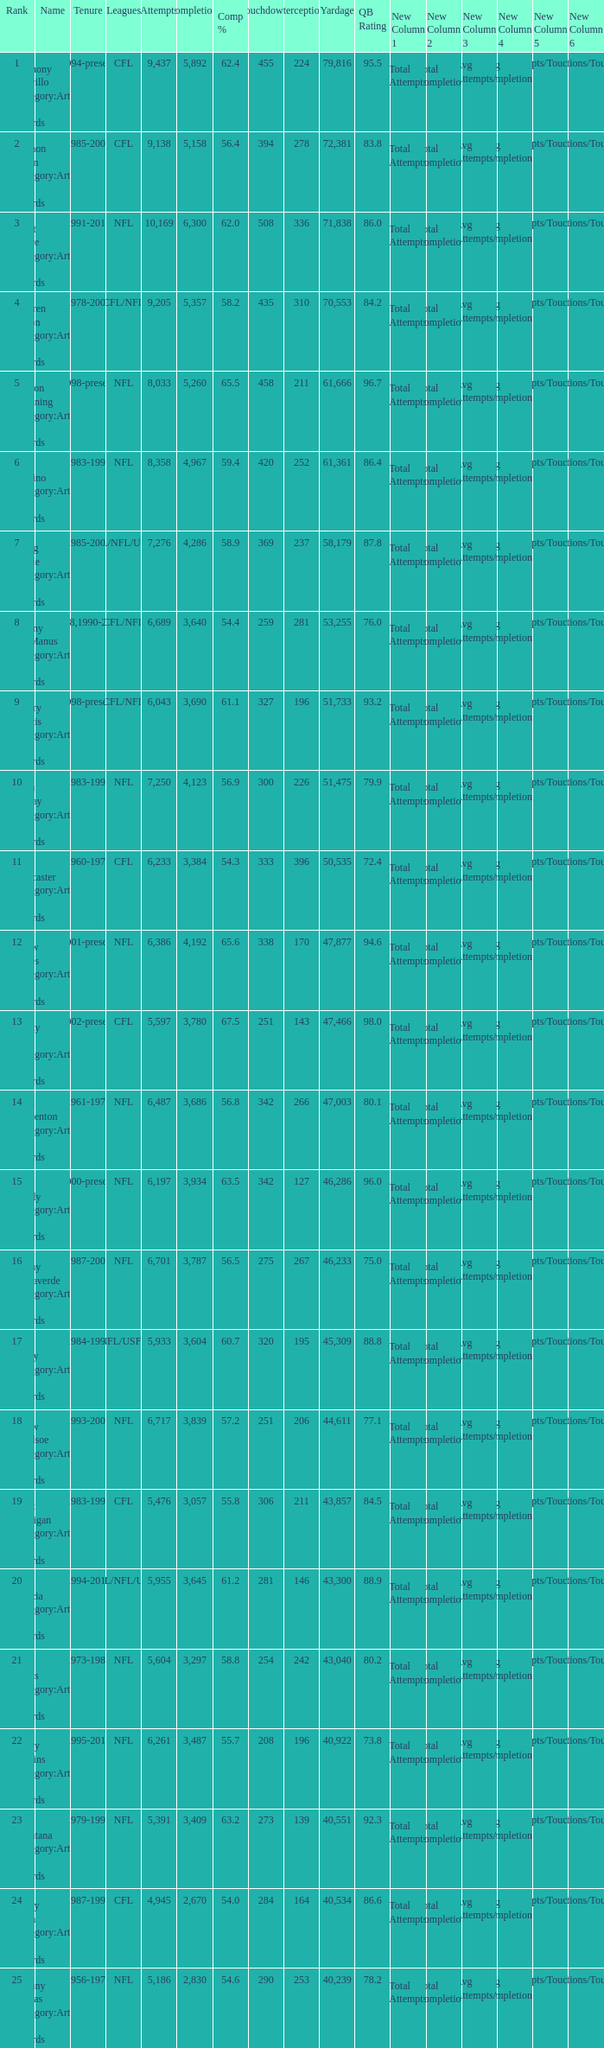What is the rank when there are more than 4,123 completion and the comp percentage is more than 65.6? None. 